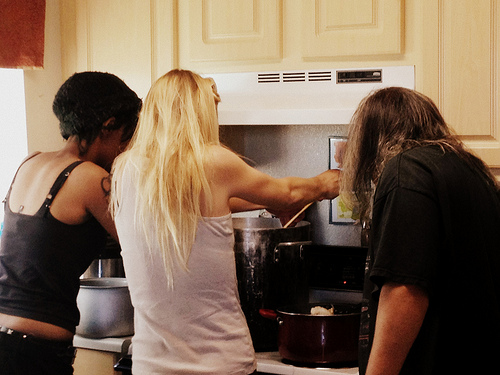<image>
Is there a painting on the wall? Yes. Looking at the image, I can see the painting is positioned on top of the wall, with the wall providing support. Where is the woman in relation to the pot? Is it behind the pot? Yes. From this viewpoint, the woman is positioned behind the pot, with the pot partially or fully occluding the woman. 